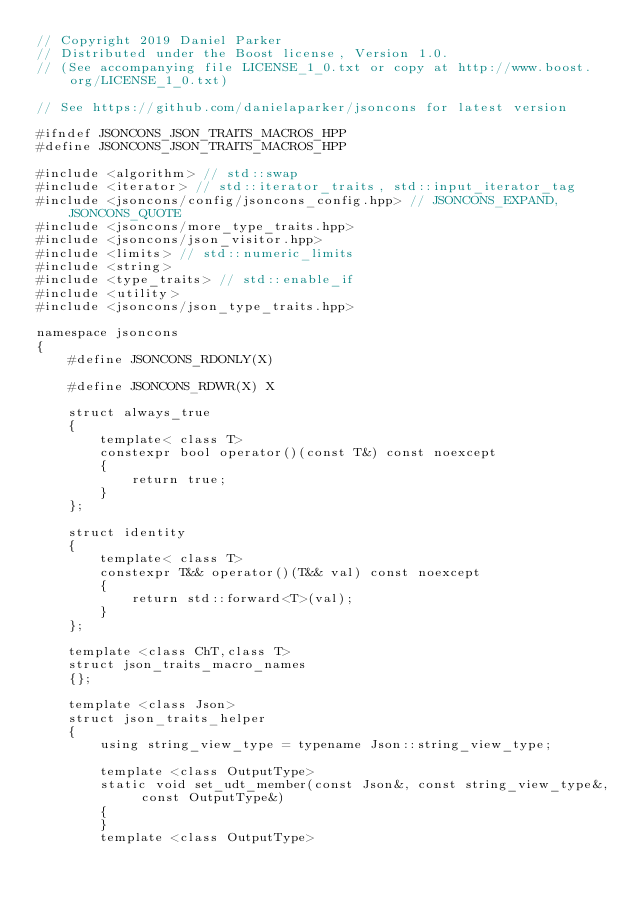<code> <loc_0><loc_0><loc_500><loc_500><_C++_>// Copyright 2019 Daniel Parker
// Distributed under the Boost license, Version 1.0.
// (See accompanying file LICENSE_1_0.txt or copy at http://www.boost.org/LICENSE_1_0.txt)

// See https://github.com/danielaparker/jsoncons for latest version

#ifndef JSONCONS_JSON_TRAITS_MACROS_HPP
#define JSONCONS_JSON_TRAITS_MACROS_HPP

#include <algorithm> // std::swap
#include <iterator> // std::iterator_traits, std::input_iterator_tag
#include <jsoncons/config/jsoncons_config.hpp> // JSONCONS_EXPAND, JSONCONS_QUOTE
#include <jsoncons/more_type_traits.hpp>
#include <jsoncons/json_visitor.hpp>
#include <limits> // std::numeric_limits
#include <string>
#include <type_traits> // std::enable_if
#include <utility>
#include <jsoncons/json_type_traits.hpp>

namespace jsoncons
{
    #define JSONCONS_RDONLY(X)

    #define JSONCONS_RDWR(X) X

    struct always_true
    {
        template< class T>
        constexpr bool operator()(const T&) const noexcept
        {
            return true;
        }
    };

    struct identity
    {
        template< class T>
        constexpr T&& operator()(T&& val) const noexcept
        {
            return std::forward<T>(val);
        }
    };

    template <class ChT,class T>
    struct json_traits_macro_names
    {};

    template <class Json>
    struct json_traits_helper
    {
        using string_view_type = typename Json::string_view_type; 

        template <class OutputType> 
        static void set_udt_member(const Json&, const string_view_type&, const OutputType&) 
        { 
        } 
        template <class OutputType> </code> 